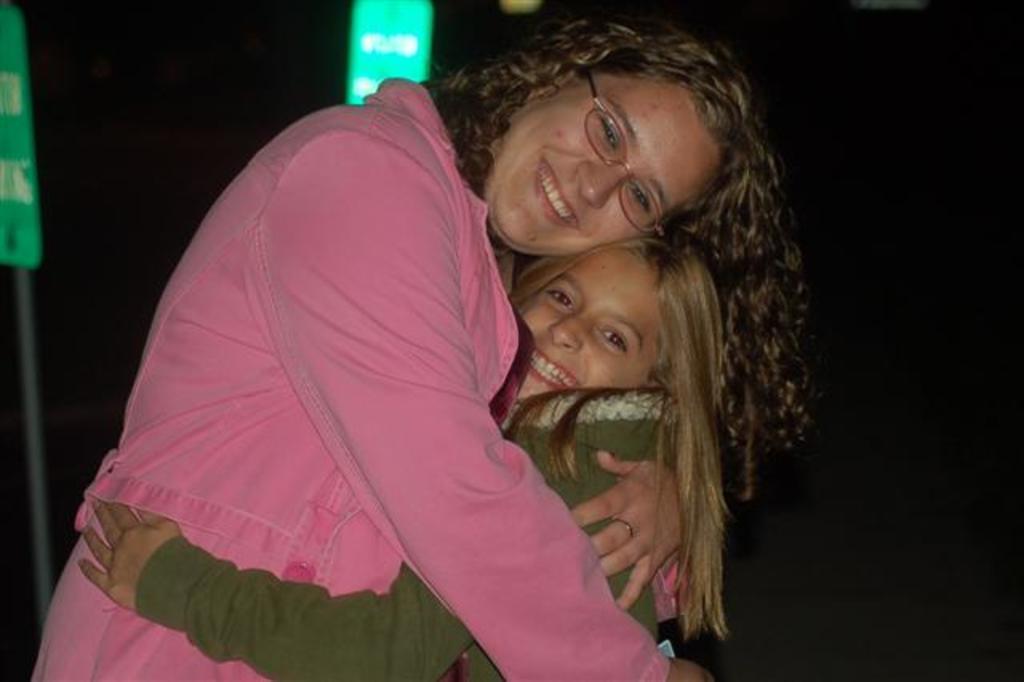In one or two sentences, can you explain what this image depicts? In the picture we can see a woman wearing pink color dress, kid wearing green color dress hugging each other and in the background of the picture there is dark view. 